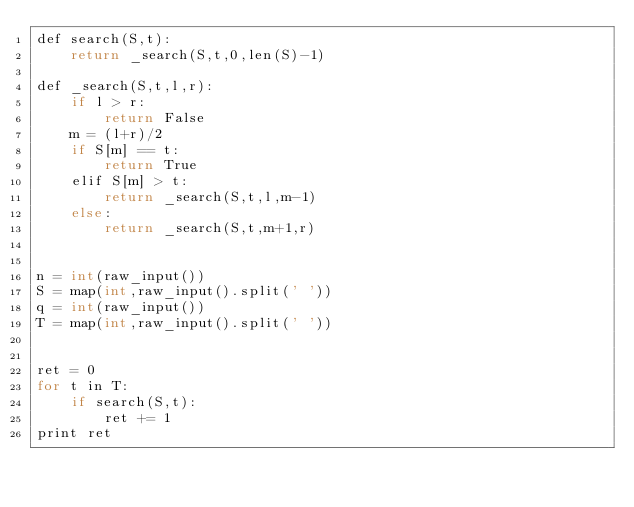Convert code to text. <code><loc_0><loc_0><loc_500><loc_500><_C++_>def search(S,t):
    return _search(S,t,0,len(S)-1)

def _search(S,t,l,r):
    if l > r:
        return False
    m = (l+r)/2
    if S[m] == t:
        return True
    elif S[m] > t:
        return _search(S,t,l,m-1)
    else:
        return _search(S,t,m+1,r)


n = int(raw_input())
S = map(int,raw_input().split(' '))
q = int(raw_input())
T = map(int,raw_input().split(' '))


ret = 0
for t in T:
    if search(S,t):
        ret += 1
print ret</code> 